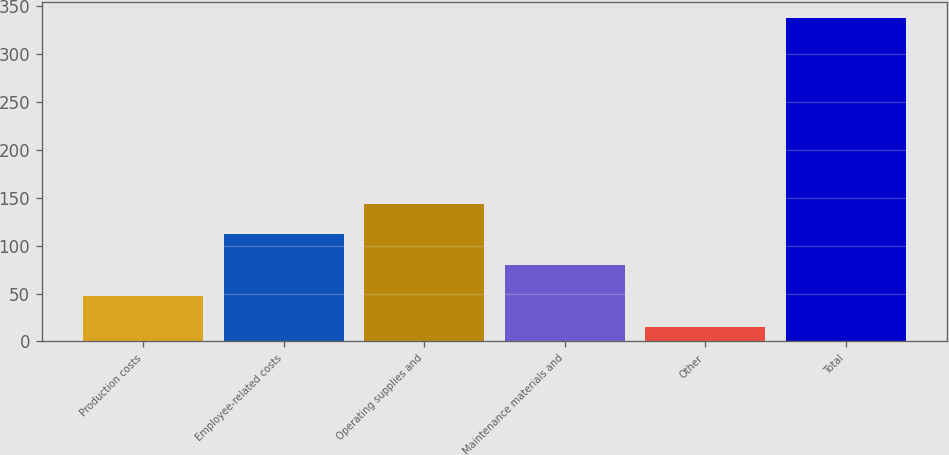Convert chart. <chart><loc_0><loc_0><loc_500><loc_500><bar_chart><fcel>Production costs<fcel>Employee-related costs<fcel>Operating supplies and<fcel>Maintenance materials and<fcel>Other<fcel>Total<nl><fcel>47.2<fcel>111.6<fcel>143.8<fcel>79.4<fcel>15<fcel>337<nl></chart> 